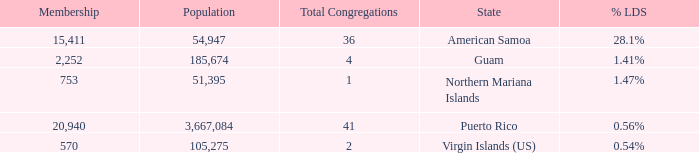What is the highest Population, when State is Puerto Rico, and when Total Congregations is greater than 41? None. 